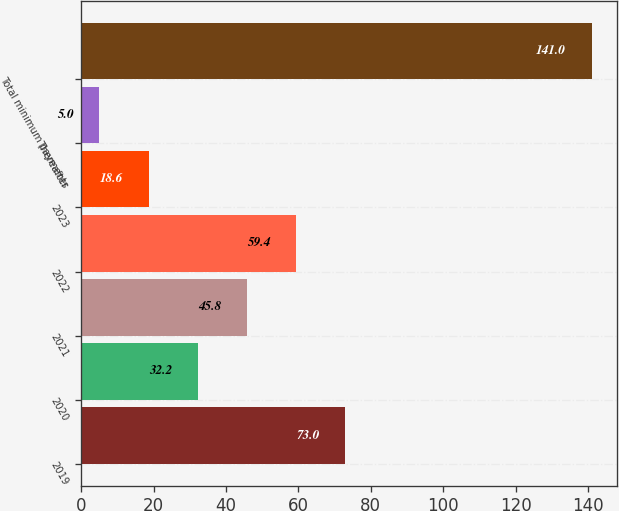Convert chart to OTSL. <chart><loc_0><loc_0><loc_500><loc_500><bar_chart><fcel>2019<fcel>2020<fcel>2021<fcel>2022<fcel>2023<fcel>Thereafter<fcel>Total minimum payments<nl><fcel>73<fcel>32.2<fcel>45.8<fcel>59.4<fcel>18.6<fcel>5<fcel>141<nl></chart> 